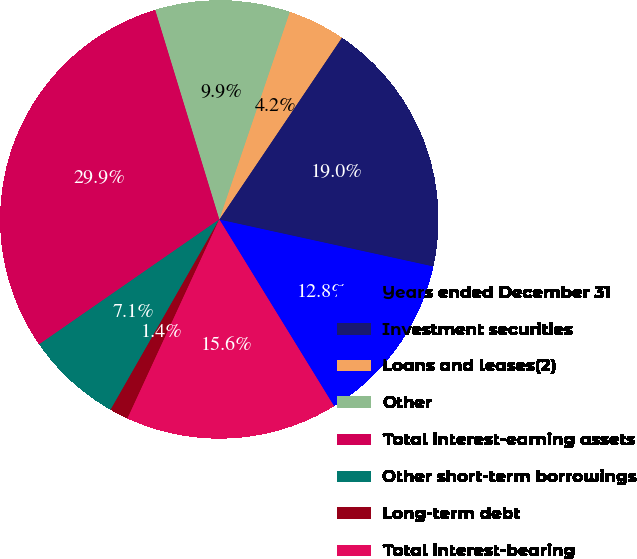Convert chart to OTSL. <chart><loc_0><loc_0><loc_500><loc_500><pie_chart><fcel>Years ended December 31<fcel>Investment securities<fcel>Loans and leases(2)<fcel>Other<fcel>Total interest-earning assets<fcel>Other short-term borrowings<fcel>Long-term debt<fcel>Total interest-bearing<nl><fcel>12.8%<fcel>19.0%<fcel>4.23%<fcel>9.94%<fcel>29.93%<fcel>7.09%<fcel>1.38%<fcel>15.65%<nl></chart> 